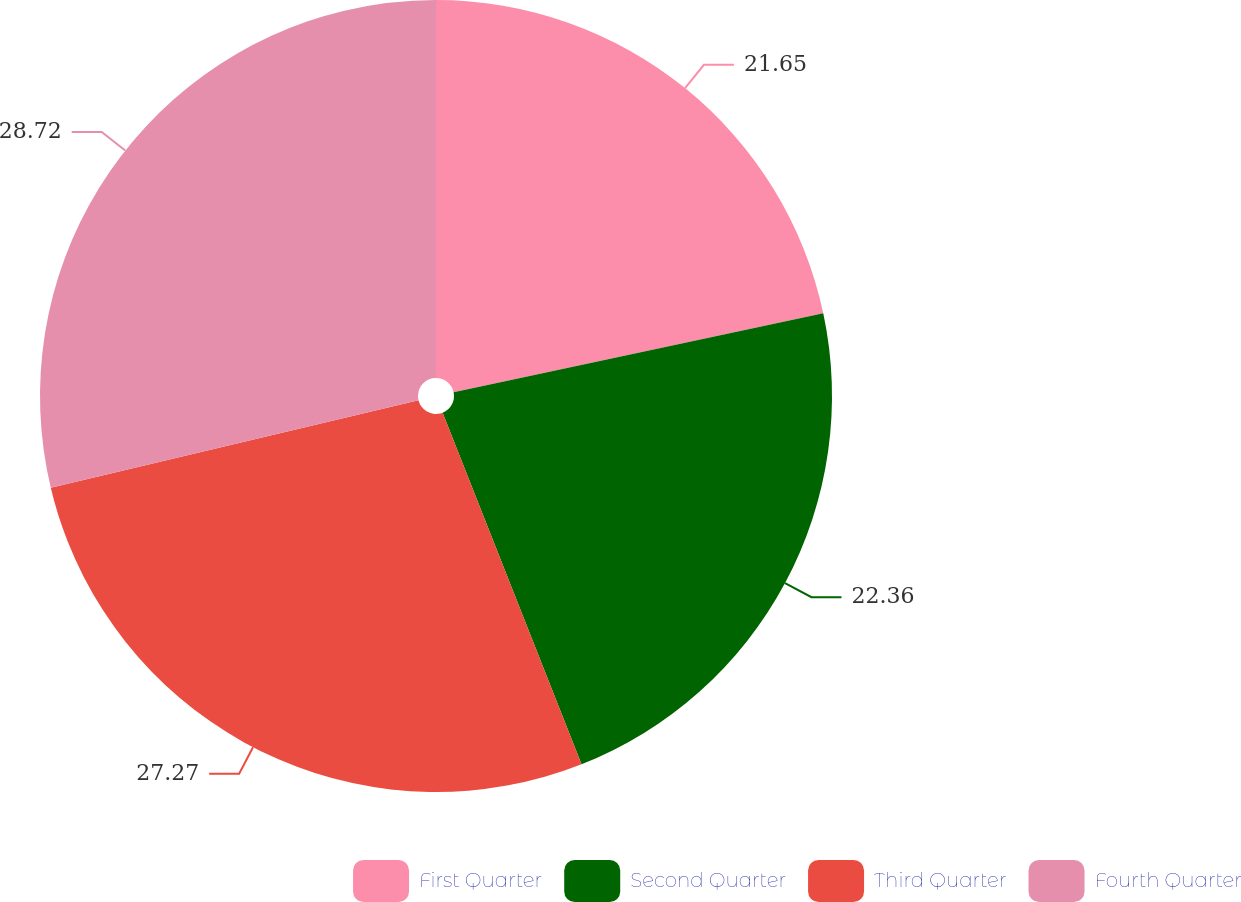Convert chart to OTSL. <chart><loc_0><loc_0><loc_500><loc_500><pie_chart><fcel>First Quarter<fcel>Second Quarter<fcel>Third Quarter<fcel>Fourth Quarter<nl><fcel>21.65%<fcel>22.36%<fcel>27.27%<fcel>28.72%<nl></chart> 